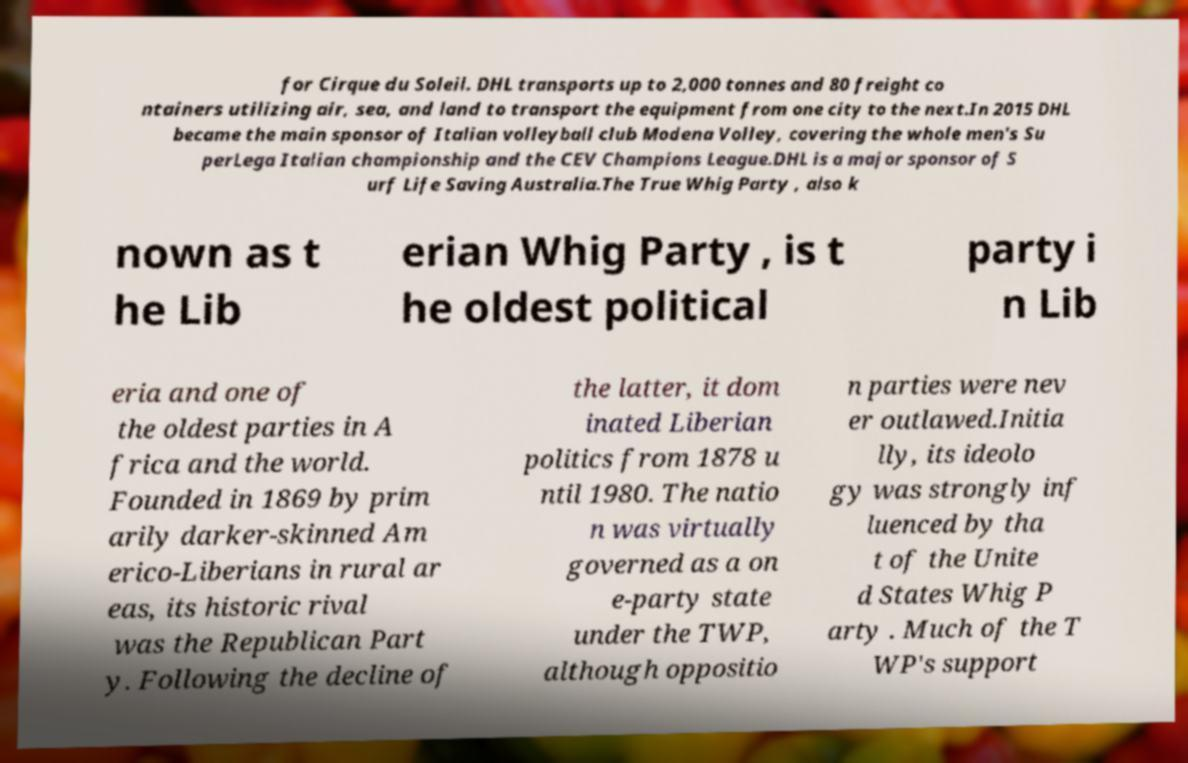What messages or text are displayed in this image? I need them in a readable, typed format. for Cirque du Soleil. DHL transports up to 2,000 tonnes and 80 freight co ntainers utilizing air, sea, and land to transport the equipment from one city to the next.In 2015 DHL became the main sponsor of Italian volleyball club Modena Volley, covering the whole men's Su perLega Italian championship and the CEV Champions League.DHL is a major sponsor of S urf Life Saving Australia.The True Whig Party , also k nown as t he Lib erian Whig Party , is t he oldest political party i n Lib eria and one of the oldest parties in A frica and the world. Founded in 1869 by prim arily darker-skinned Am erico-Liberians in rural ar eas, its historic rival was the Republican Part y. Following the decline of the latter, it dom inated Liberian politics from 1878 u ntil 1980. The natio n was virtually governed as a on e-party state under the TWP, although oppositio n parties were nev er outlawed.Initia lly, its ideolo gy was strongly inf luenced by tha t of the Unite d States Whig P arty . Much of the T WP's support 